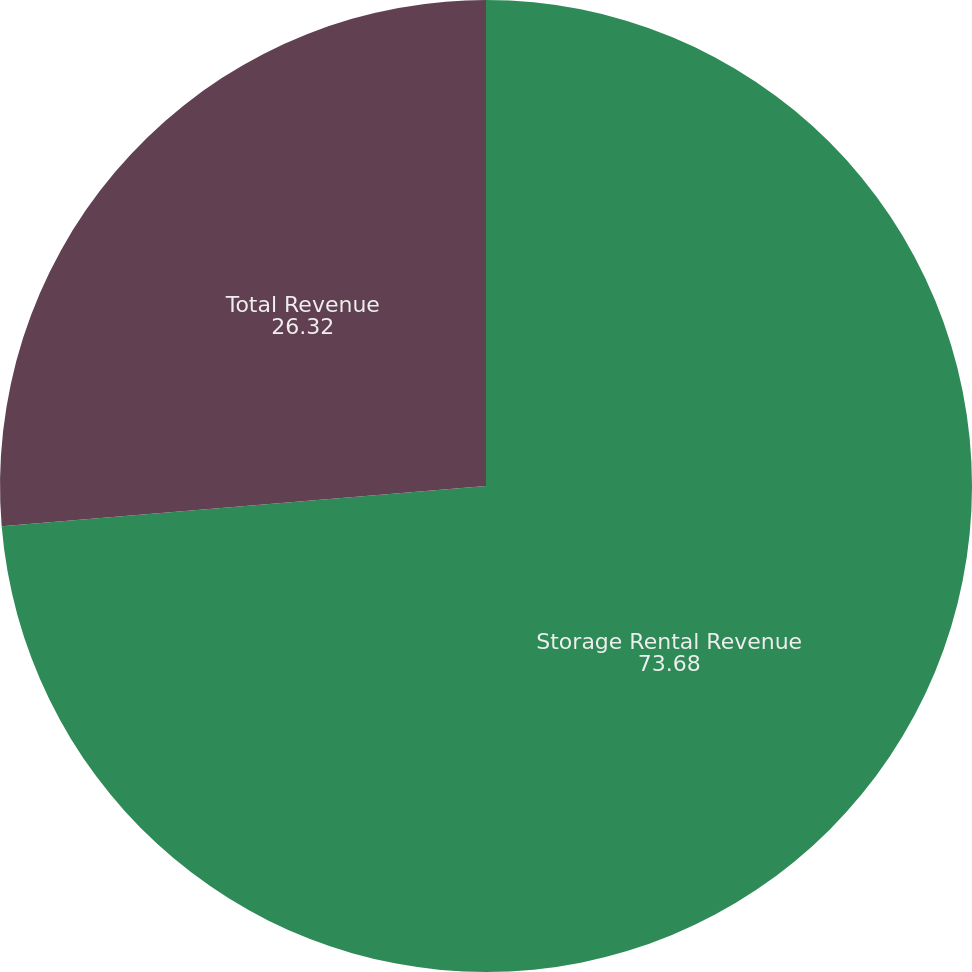Convert chart to OTSL. <chart><loc_0><loc_0><loc_500><loc_500><pie_chart><fcel>Storage Rental Revenue<fcel>Total Revenue<nl><fcel>73.68%<fcel>26.32%<nl></chart> 